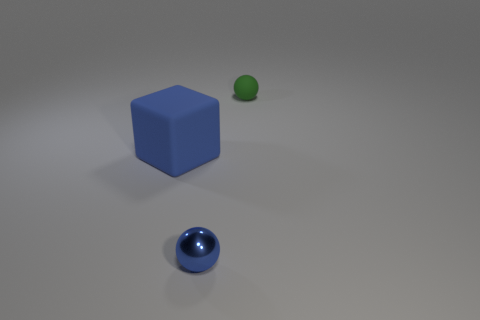Add 3 tiny green spheres. How many objects exist? 6 Subtract all spheres. How many objects are left? 1 Add 1 tiny green matte things. How many tiny green matte things exist? 2 Subtract 1 green spheres. How many objects are left? 2 Subtract all tiny green rubber objects. Subtract all green rubber things. How many objects are left? 1 Add 3 tiny balls. How many tiny balls are left? 5 